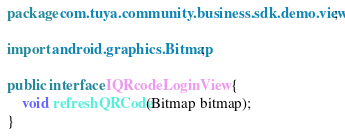<code> <loc_0><loc_0><loc_500><loc_500><_Java_>package com.tuya.community.business.sdk.demo.view;

import android.graphics.Bitmap;

public interface IQRcodeLoginView {
    void refreshQRCode(Bitmap bitmap);
}
</code> 